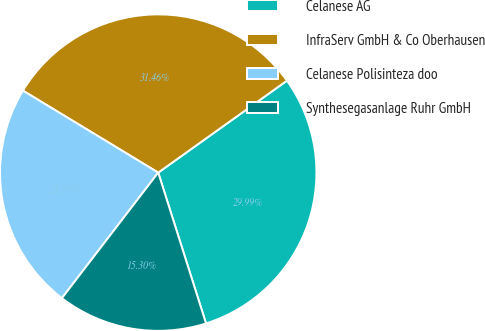<chart> <loc_0><loc_0><loc_500><loc_500><pie_chart><fcel>Celanese AG<fcel>InfraServ GmbH & Co Oberhausen<fcel>Celanese Polisinteza doo<fcel>Synthesegasanlage Ruhr GmbH<nl><fcel>29.99%<fcel>31.46%<fcel>23.26%<fcel>15.3%<nl></chart> 